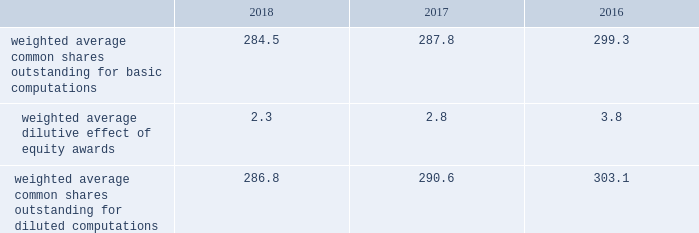Note 2 2013 earnings per share the weighted average number of shares outstanding used to compute earnings per common share were as follows ( in millions ) : .
We compute basic and diluted earnings per common share by dividing net earnings by the respective weighted average number of common shares outstanding for the periods presented .
Our calculation of diluted earnings per common share also includes the dilutive effects for the assumed vesting of outstanding restricted stock units ( rsus ) , performance stock units ( psus ) and exercise of outstanding stock options based on the treasury stock method .
There were no significant anti-dilutive equity awards for the years ended december 31 , 2018 , 2017 and 2016 .
Note 3 2013 acquisition and divestitures consolidation of awe management limited on august 24 , 2016 , we increased our ownership interest in the awe joint venture , which operates the united kingdom 2019s nuclear deterrent program , from 33% ( 33 % ) to 51% ( 51 % ) .
Consequently , we began consolidating awe and our operating results include 100% ( 100 % ) of awe 2019s sales and 51% ( 51 % ) of its operating profit .
Prior to increasing our ownership interest , we accounted for our investment in awe using the equity method of accounting .
Under the equity method , we recognized only 33% ( 33 % ) of awe 2019s earnings or losses and no sales .
Accordingly , prior to august 24 , 2016 , the date we obtained control , we recorded 33% ( 33 % ) of awe 2019s net earnings in our operating results and subsequent to august 24 , 2016 , we recognized 100% ( 100 % ) of awe 2019s sales and 51% ( 51 % ) of its operating profit .
We accounted for this transaction as a 201cstep acquisition 201d ( as defined by u.s .
Gaap ) , which requires us to consolidate and record the assets and liabilities of awe at fair value .
Accordingly , we recorded intangible assets of $ 243 million related to customer relationships , $ 32 million of net liabilities , and noncontrolling interests of $ 107 million .
The intangible assets are being amortized over a period of eight years in accordance with the underlying pattern of economic benefit reflected by the future net cash flows .
In 2016 , we recognized a non-cash net gain of $ 104 million associated with obtaining a controlling interest in awe , which consisted of a $ 127 million pretax gain recognized in the operating results of our space business segment and $ 23 million of tax-related items at our corporate office .
The gain represented the fair value of our 51% ( 51 % ) interest in awe , less the carrying value of our previously held investment in awe and deferred taxes .
The gain was recorded in other income , net on our consolidated statements of earnings .
The fair value of awe ( including the intangible assets ) , our controlling interest , and the noncontrolling interests were determined using the income approach .
Divestiture of the information systems & global solutions business on august 16 , 2016 , we divested our former is&gs business , which merged with leidos , in a reverse morris trust transaction ( the 201ctransaction 201d ) .
The transaction was completed in a multi-step process pursuant to which we initially contributed the is&gs business to abacus innovations corporation ( abacus ) , a wholly owned subsidiary of lockheed martin created to facilitate the transaction , and the common stock of abacus was distributed to participating lockheed martin stockholders through an exchange offer .
Under the terms of the exchange offer , lockheed martin stockholders had the option to exchange shares of lockheed martin common stock for shares of abacus common stock .
At the conclusion of the exchange offer , all shares of abacus common stock were exchanged for 9369694 shares of lockheed martin common stock held by lockheed martin stockholders that elected to participate in the exchange .
The shares of lockheed martin common stock that were exchanged and accepted were retired , reducing the number of shares of our common stock outstanding by approximately 3% ( 3 % ) .
Following the exchange offer , abacus merged with a subsidiary of leidos , with abacus continuing as the surviving corporation and a wholly-owned subsidiary of leidos .
As part of the merger , each share of abacus common stock was automatically converted into one share of leidos common stock .
We did not receive any shares of leidos common stock as part of the transaction and do not hold any shares of leidos or abacus common stock following the transaction .
Based on an opinion of outside tax counsel , subject to customary qualifications and based on factual representations , the exchange offer and merger will qualify as tax-free transactions to lockheed martin and its stockholders , except to the extent that cash was paid to lockheed martin stockholders in lieu of fractional shares .
In connection with the transaction , abacus borrowed an aggregate principal amount of approximately $ 1.84 billion under term loan facilities with third party financial institutions , the proceeds of which were used to make a one-time special cash payment of $ 1.80 billion to lockheed martin and to pay associated borrowing fees and expenses .
The entire special cash payment was used to repay debt , pay dividends and repurchase stock during the third and fourth quarters of 2016 .
The obligations under the abacus term loan facilities were guaranteed by leidos as part of the transaction. .
What was the percent of the tax associated with the acquisition of the controlling effect in awe in 2016? 
Computations: (23 / 127)
Answer: 0.1811. 